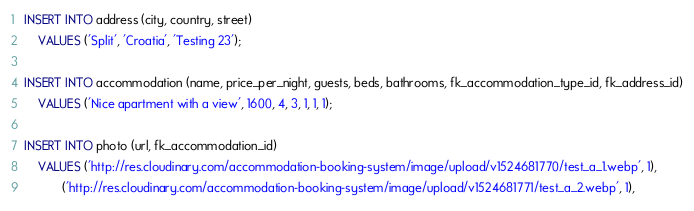<code> <loc_0><loc_0><loc_500><loc_500><_SQL_>INSERT INTO address (city, country, street)
    VALUES ('Split', 'Croatia', 'Testing 23');

INSERT INTO accommodation (name, price_per_night, guests, beds, bathrooms, fk_accommodation_type_id, fk_address_id)
    VALUES ('Nice apartment with a view', 1600, 4, 3, 1, 1, 1);

INSERT INTO photo (url, fk_accommodation_id)
    VALUES ('http://res.cloudinary.com/accommodation-booking-system/image/upload/v1524681770/test_a_1.webp', 1),
           ('http://res.cloudinary.com/accommodation-booking-system/image/upload/v1524681771/test_a_2.webp', 1),</code> 